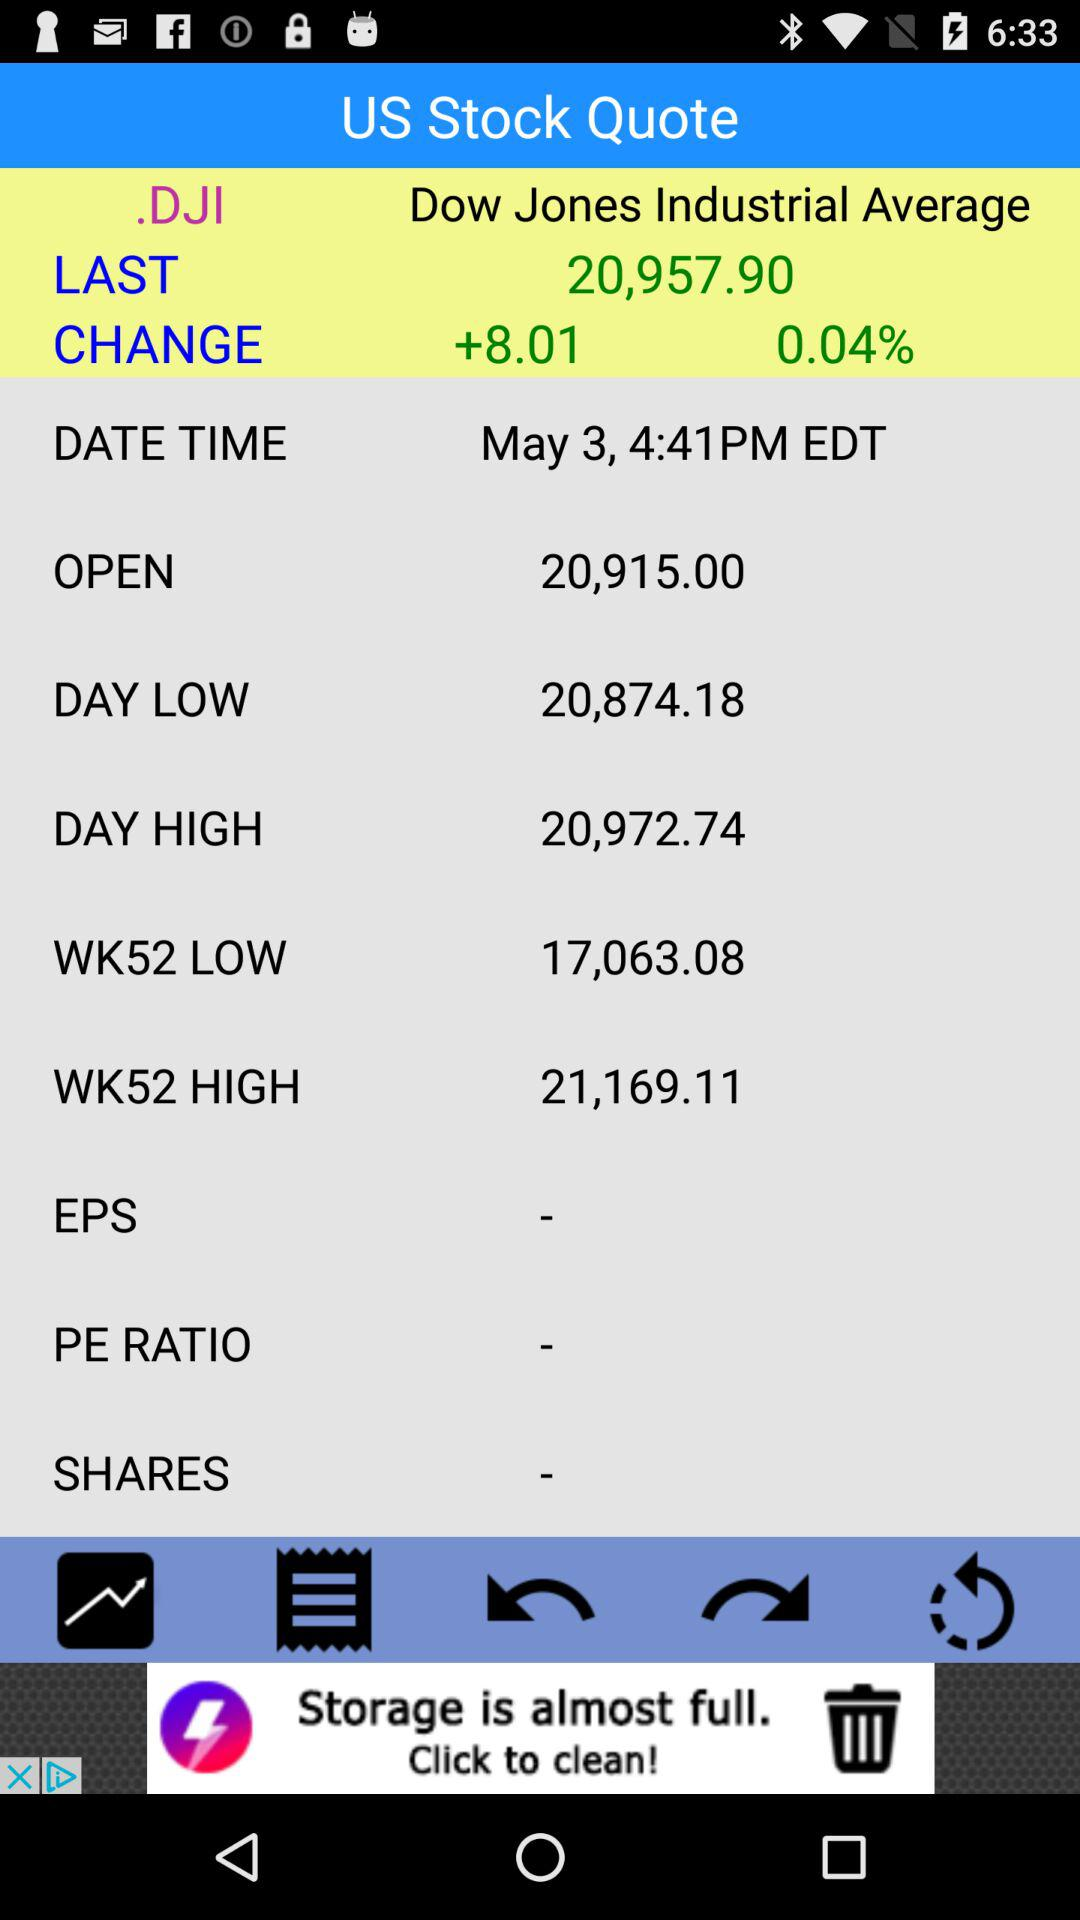What is the last traded price of "Dow Jones Industrial Average"? The last traded price of "Dow Jones Industrial Average" is 20,957.90. 